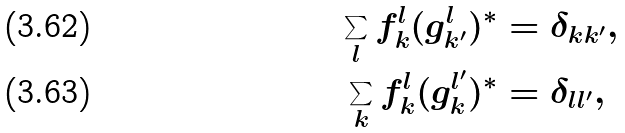Convert formula to latex. <formula><loc_0><loc_0><loc_500><loc_500>\sum _ { l } f _ { k } ^ { l } ( g _ { k ^ { \prime } } ^ { l } ) ^ { \ast } & = \delta _ { k k ^ { \prime } } , \\ \sum _ { k } f _ { k } ^ { l } ( g _ { k } ^ { l ^ { \prime } } ) ^ { \ast } & = \delta _ { l l ^ { \prime } } ,</formula> 